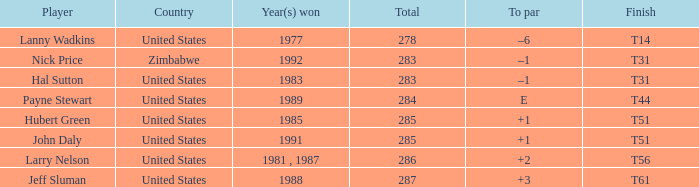I'm looking to parse the entire table for insights. Could you assist me with that? {'header': ['Player', 'Country', 'Year(s) won', 'Total', 'To par', 'Finish'], 'rows': [['Lanny Wadkins', 'United States', '1977', '278', '–6', 'T14'], ['Nick Price', 'Zimbabwe', '1992', '283', '–1', 'T31'], ['Hal Sutton', 'United States', '1983', '283', '–1', 'T31'], ['Payne Stewart', 'United States', '1989', '284', 'E', 'T44'], ['Hubert Green', 'United States', '1985', '285', '+1', 'T51'], ['John Daly', 'United States', '1991', '285', '+1', 'T51'], ['Larry Nelson', 'United States', '1981 , 1987', '286', '+2', 'T56'], ['Jeff Sluman', 'United States', '1988', '287', '+3', 'T61']]} What is Finish, when Year(s) Won is "1991"? T51. 